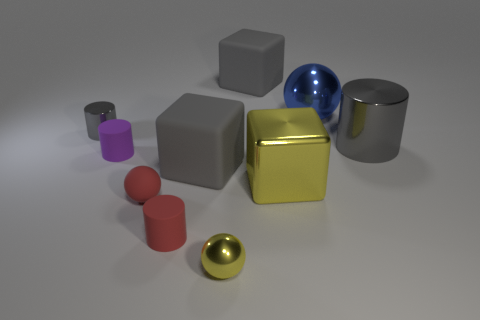Is there anything else that has the same material as the large blue ball?
Make the answer very short. Yes. There is a small thing that is the same color as the large metal cylinder; what is its shape?
Provide a short and direct response. Cylinder. What size is the ball that is the same color as the metal cube?
Make the answer very short. Small. There is a gray rubber block behind the blue metal object; does it have the same size as the tiny purple matte cylinder?
Your response must be concise. No. What is the shape of the large matte object in front of the big blue thing?
Provide a short and direct response. Cube. Is the number of small spheres greater than the number of small metal spheres?
Your answer should be very brief. Yes. There is a big cube left of the yellow metal ball; is its color the same as the tiny metallic sphere?
Provide a succinct answer. No. What number of things are gray metallic objects that are on the right side of the blue ball or big gray things behind the tiny purple cylinder?
Your answer should be compact. 2. How many metallic balls are behind the purple cylinder and in front of the large blue shiny sphere?
Give a very brief answer. 0. Are the red ball and the large sphere made of the same material?
Provide a succinct answer. No. 